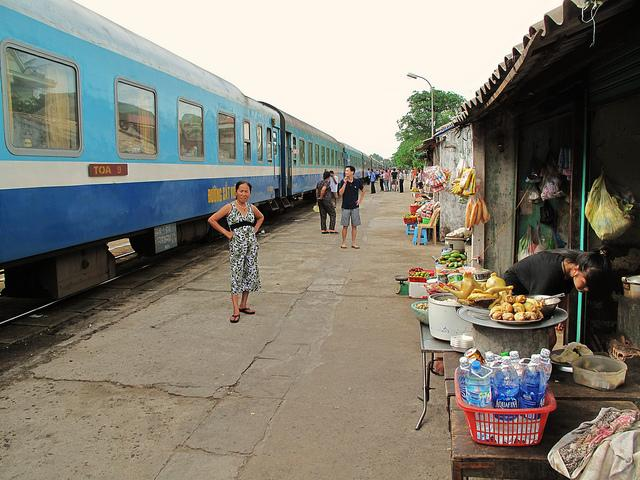What is the person on the right selling? food 